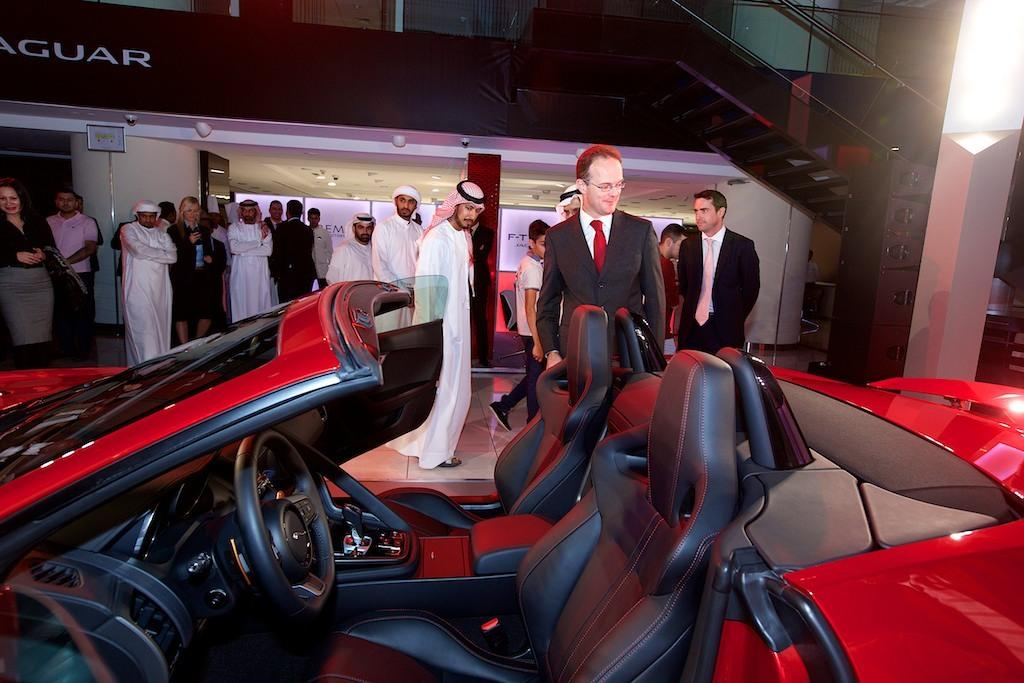What color is the car in the image? The car in the image is red. What else can be seen in the image besides the car? There are people standing in the image, and there are stairs visible as well. Can you see a rabbit hopping on the car's roof in the image? No, there is no rabbit present in the image. 